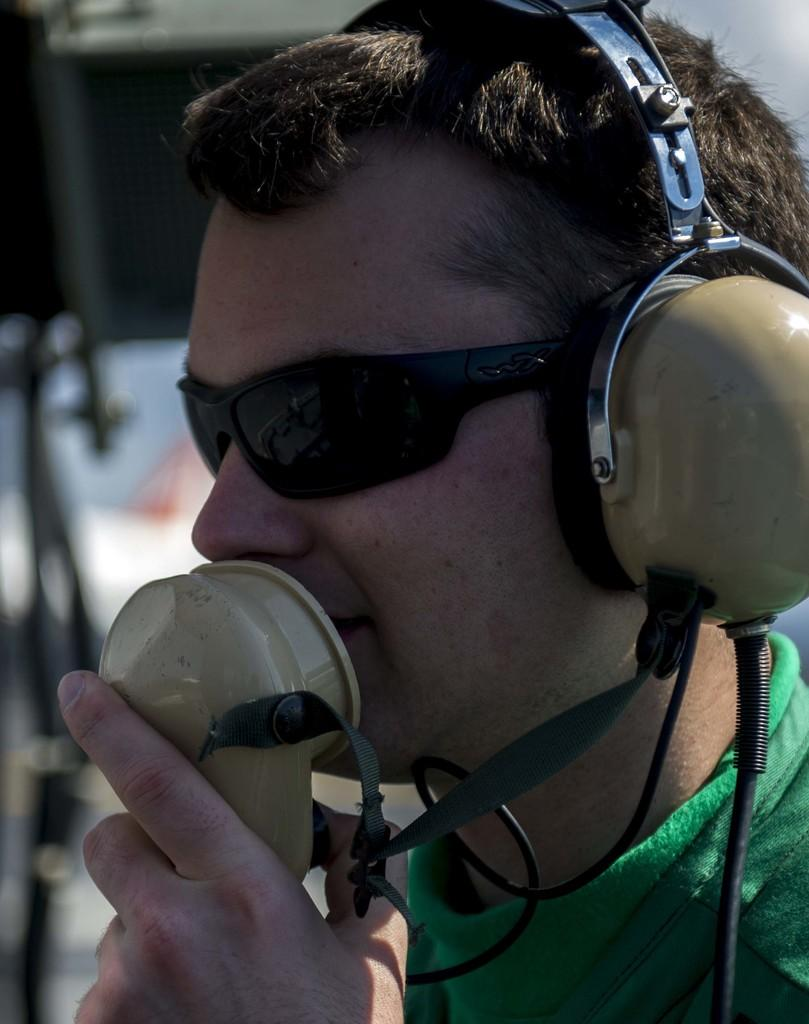What is the man in the image doing? The man is speaking into a microphone. What is the man wearing on his head? The man is wearing a headset. What type of eyewear is the man wearing? The man is wearing spectacles. What type of clothing is the man wearing on his upper body? The man is wearing a t-shirt. What type of current is the man using to power the microphone in the image? The image does not provide information about the type of current used to power the microphone. Can you see a receipt in the man's hand in the image? There is no receipt visible in the man's hand in the image. 